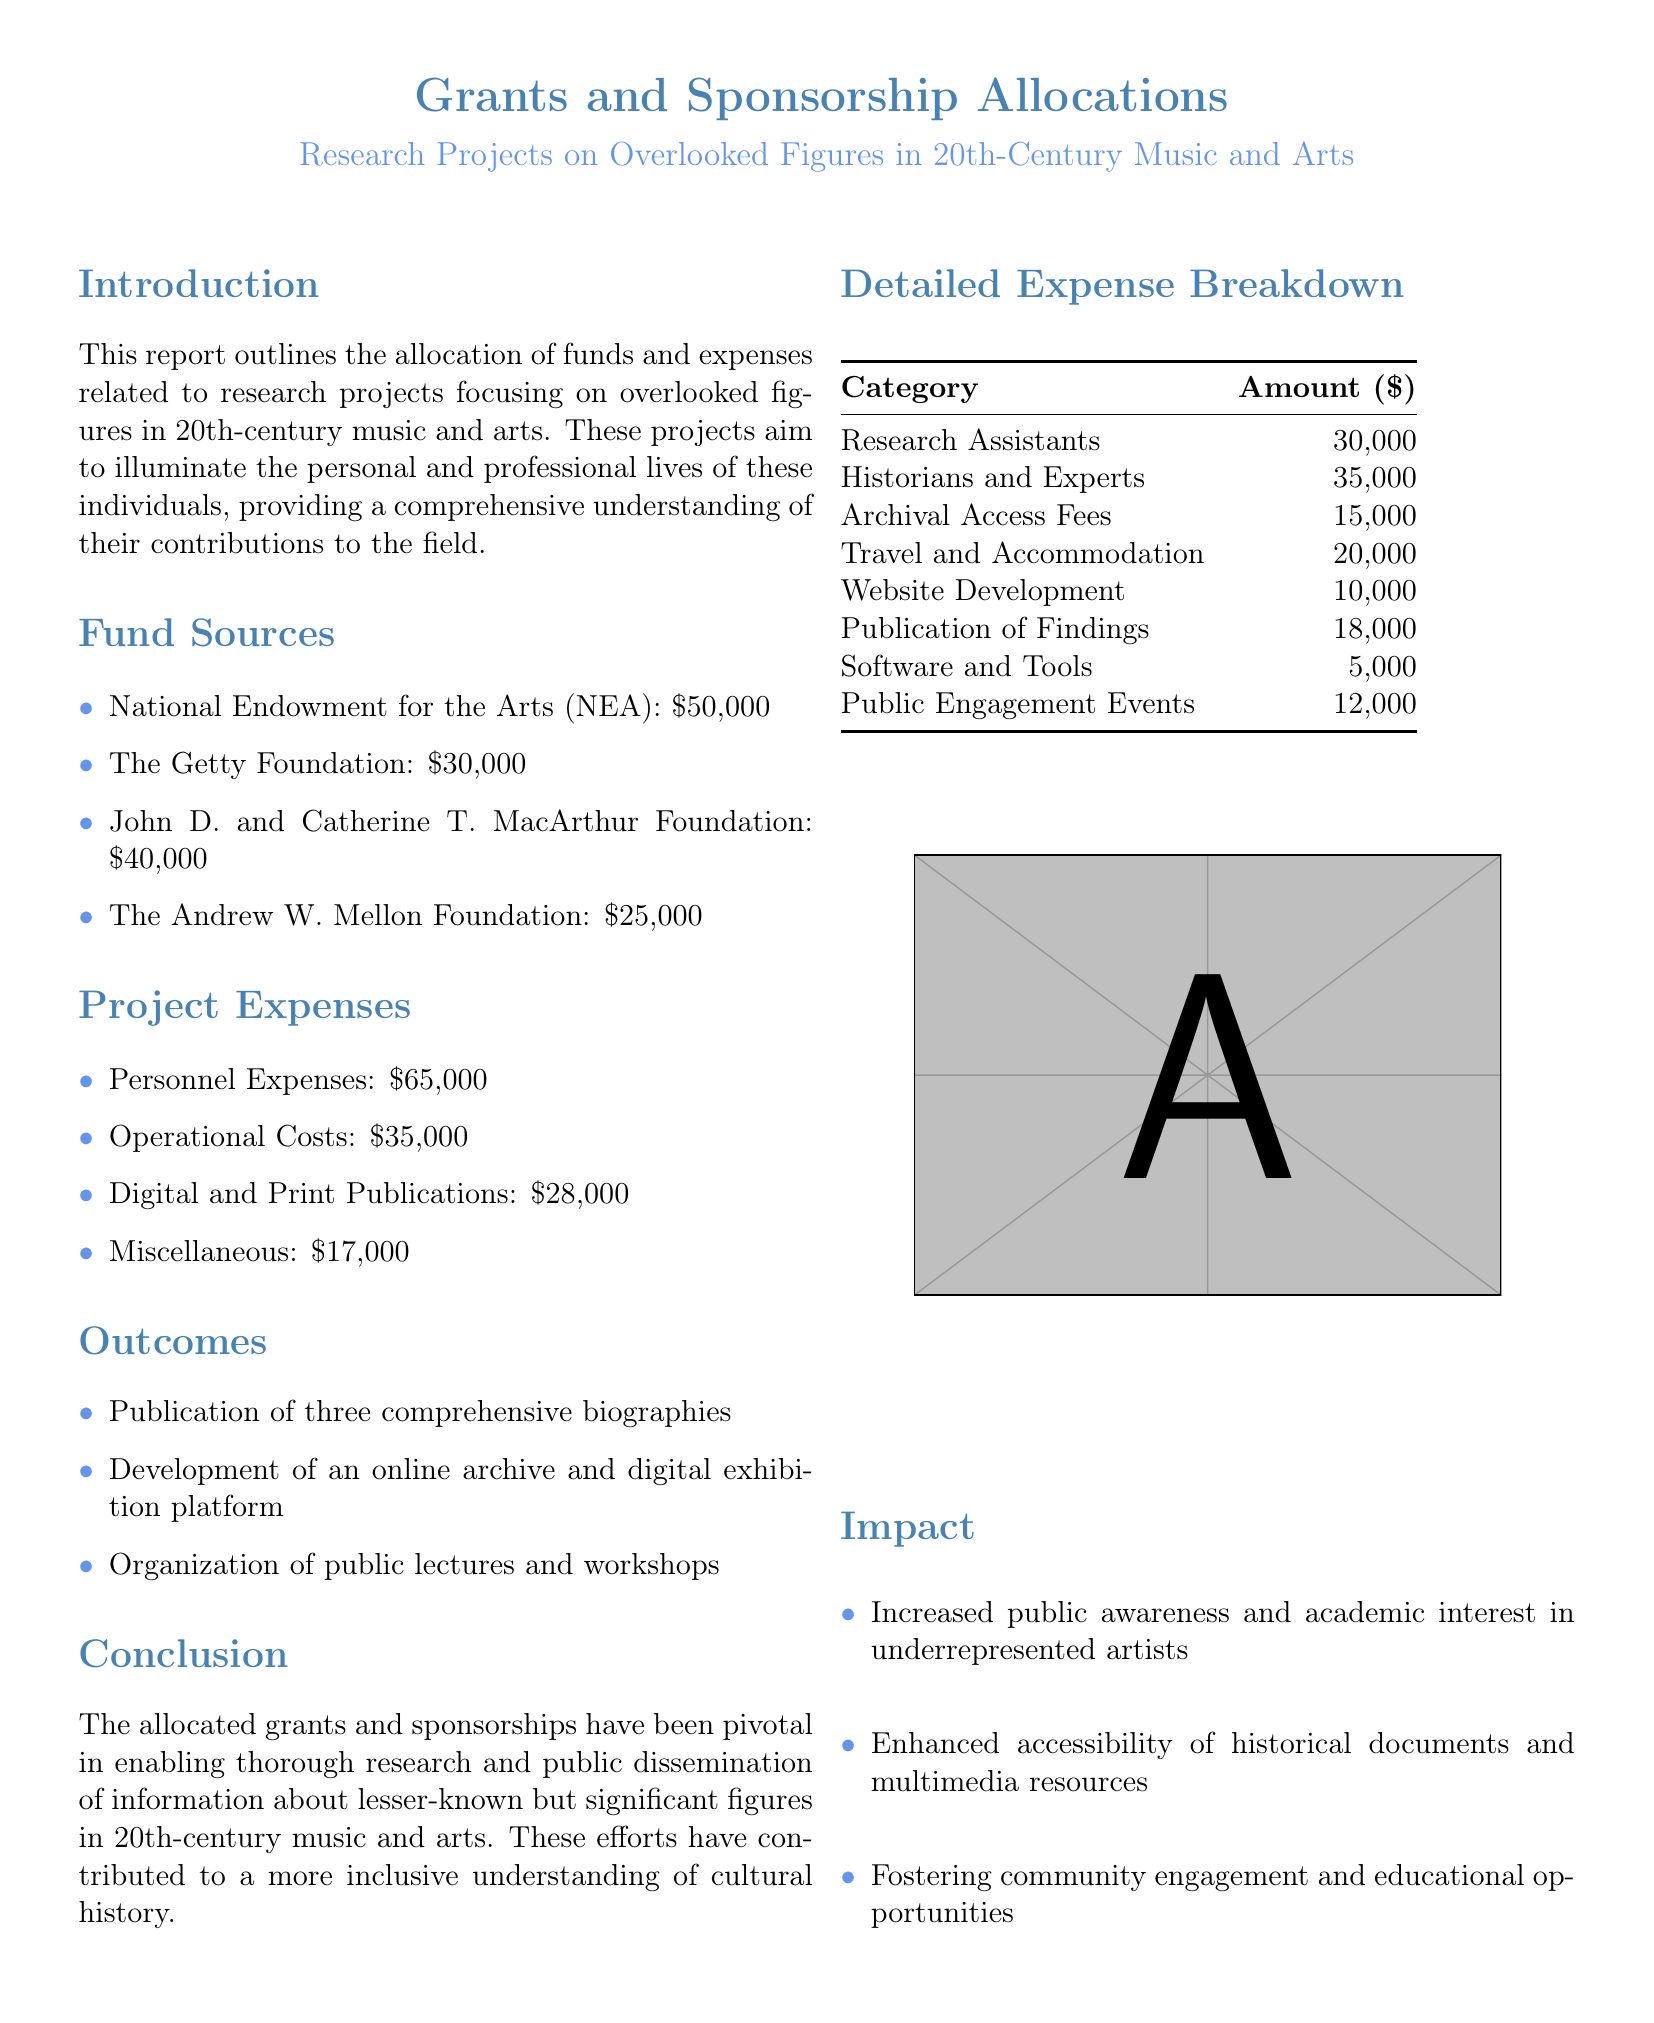What are the fund sources listed in the report? The fund sources include National Endowment for the Arts (NEA), The Getty Foundation, John D. and Catherine T. MacArthur Foundation, and The Andrew W. Mellon Foundation.
Answer: NEA, The Getty Foundation, MacArthur Foundation, Mellon Foundation What was the total amount allocated from the National Endowment for the Arts? The specific amount allocated from the National Endowment for the Arts is detailed in the fund sources section.
Answer: $50,000 How much was spent on personnel expenses? The document specifies that the personnel expenses amount is one of the project expenses listed.
Answer: $65,000 What was one of the outcomes of the research projects? The outcomes section lists several items achieved through the research projects, including publications and online platforms.
Answer: Publication of three comprehensive biographies What was the total spent on digital and print publications? The document includes a breakdown of project expenses that shows the amount spent on digital and print publications.
Answer: $28,000 How much was allocated for public engagement events? The detailed expense breakdown includes various project expenses, including the amount for public engagement events.
Answer: $12,000 What is the total allocated funding from all sources? The total funding can be calculated by summing all amounts from the fund sources provided in the document.
Answer: $145,000 What was the expense for software and tools? The detailed expense breakdown lists the expenses for various categories, including software and tools.
Answer: $5,000 What category had the highest expenditure? By analyzing the detailed expense breakdown, it's determined which category had the highest amount spent.
Answer: Personnel Expenses 